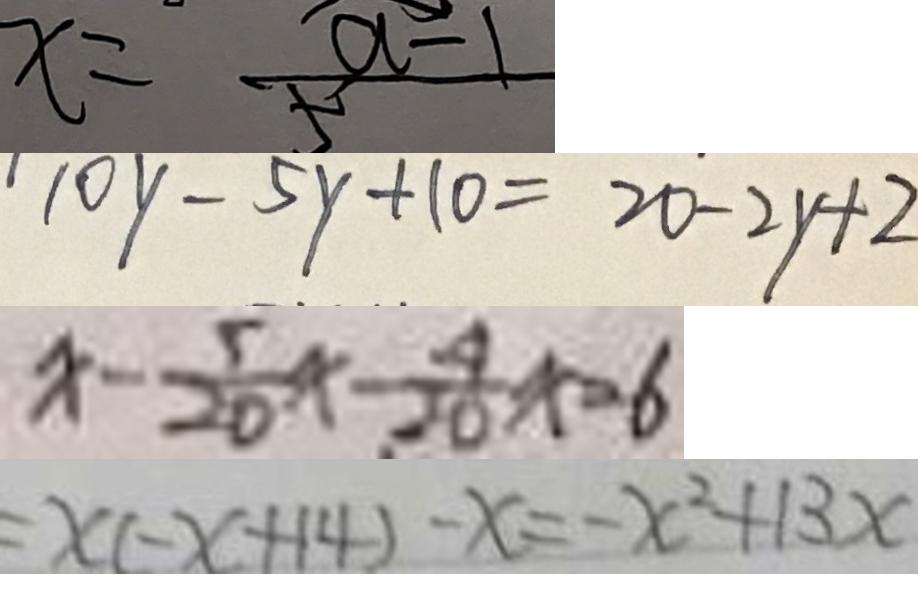Convert formula to latex. <formula><loc_0><loc_0><loc_500><loc_500>x = \frac { a - 1 } { 5 } 
 1 0 y - 5 y + 1 0 = 2 0 - 2 y + 2 
 x - \frac { 5 } { 2 0 } x - \frac { 4 } { 2 0 } x = 6 
 = x ( - x + 1 4 ) - x = - x ^ { 2 } + 1 3 x</formula> 